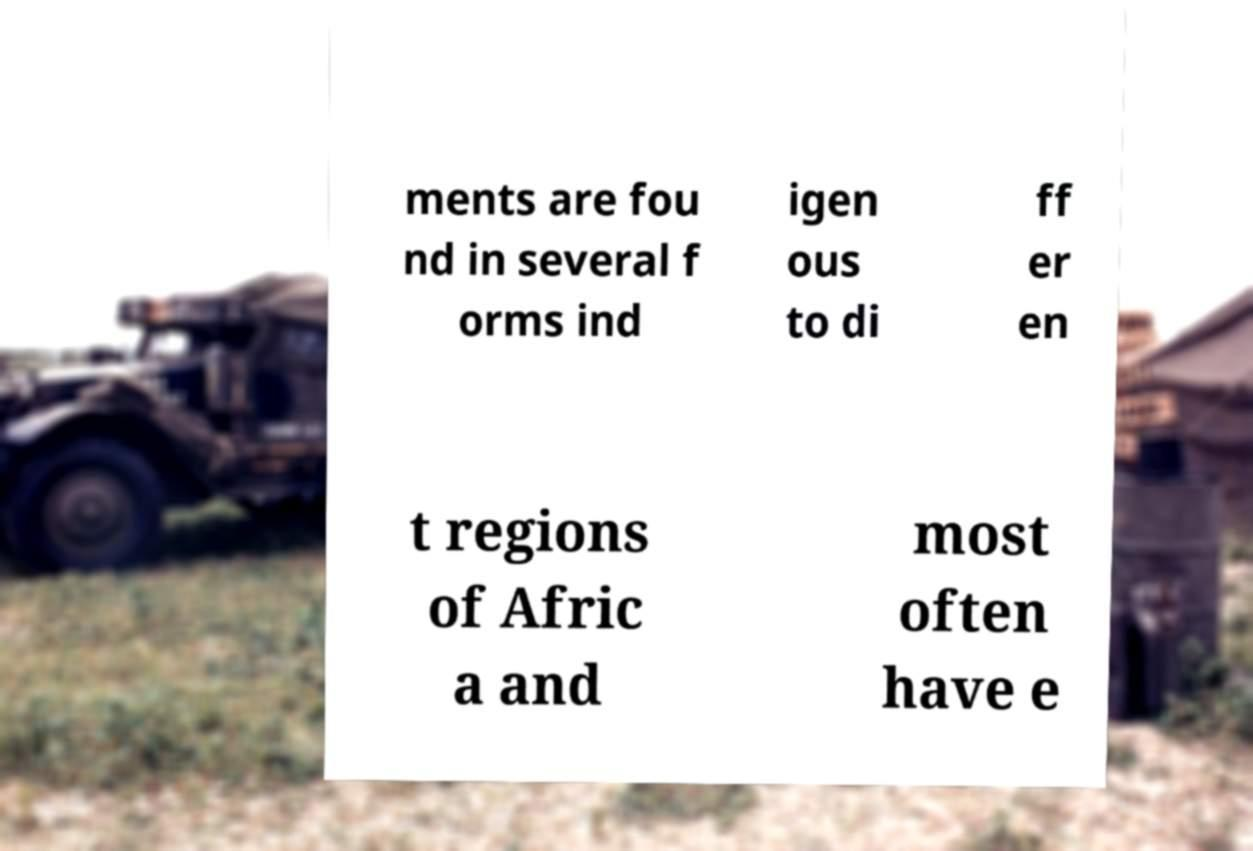There's text embedded in this image that I need extracted. Can you transcribe it verbatim? ments are fou nd in several f orms ind igen ous to di ff er en t regions of Afric a and most often have e 